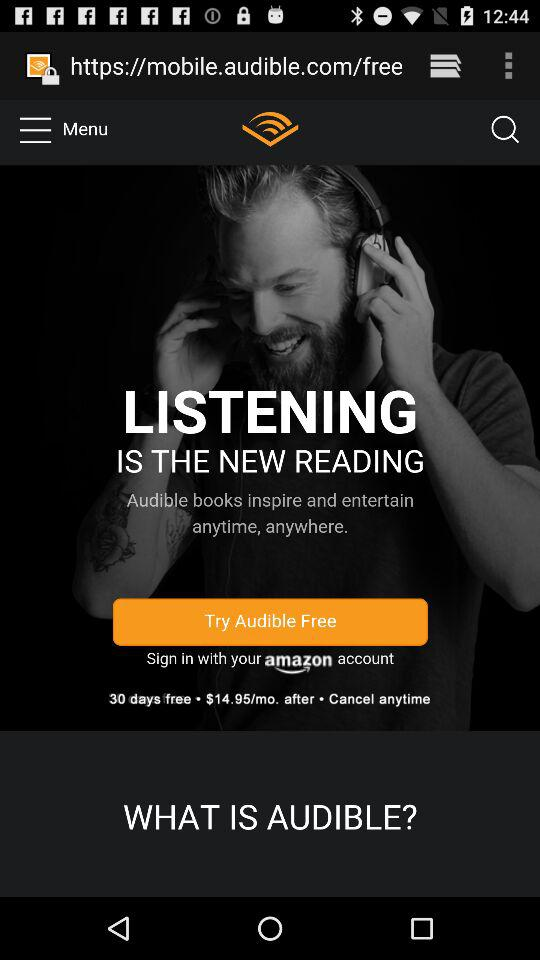What is the number of free trial days? The number of free trial days is 30. 